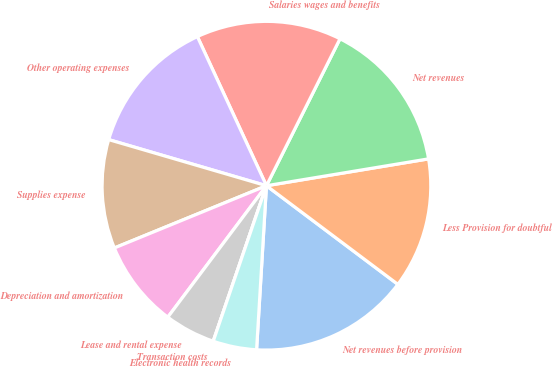Convert chart. <chart><loc_0><loc_0><loc_500><loc_500><pie_chart><fcel>Net revenues before provision<fcel>Less Provision for doubtful<fcel>Net revenues<fcel>Salaries wages and benefits<fcel>Other operating expenses<fcel>Supplies expense<fcel>Depreciation and amortization<fcel>Lease and rental expense<fcel>Transaction costs<fcel>Electronic health records<nl><fcel>15.71%<fcel>12.86%<fcel>15.0%<fcel>14.29%<fcel>13.57%<fcel>10.71%<fcel>8.57%<fcel>5.0%<fcel>0.0%<fcel>4.29%<nl></chart> 